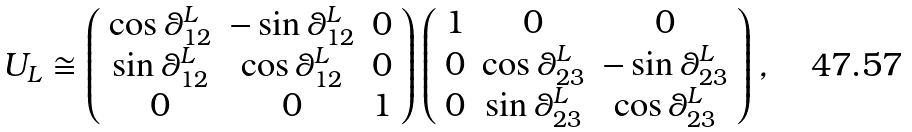<formula> <loc_0><loc_0><loc_500><loc_500>U _ { L } \cong \left ( \begin{array} { c c c } \cos \theta _ { 1 2 } ^ { L } & - \sin \theta _ { 1 2 } ^ { L } & 0 \\ \sin \theta _ { 1 2 } ^ { L } & \cos \theta _ { 1 2 } ^ { L } & 0 \\ 0 & 0 & 1 \end{array} \right ) \left ( \begin{array} { c c c } 1 & 0 & 0 \\ 0 & \cos \theta _ { 2 3 } ^ { L } & - \sin \theta _ { 2 3 } ^ { L } \\ 0 & \sin \theta _ { 2 3 } ^ { L } & \cos \theta _ { 2 3 } ^ { L } \end{array} \right ) ,</formula> 